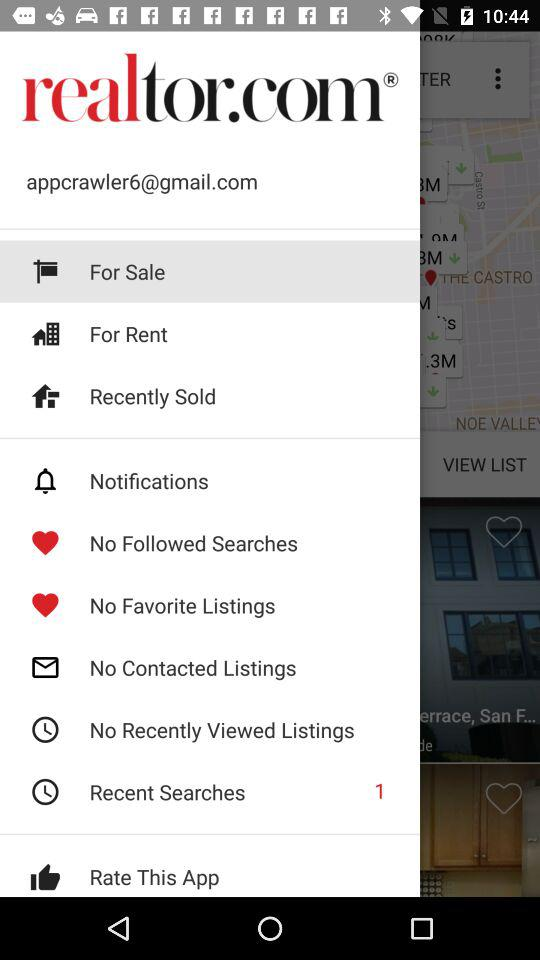What is the application name? The application name is "realtor.com". 